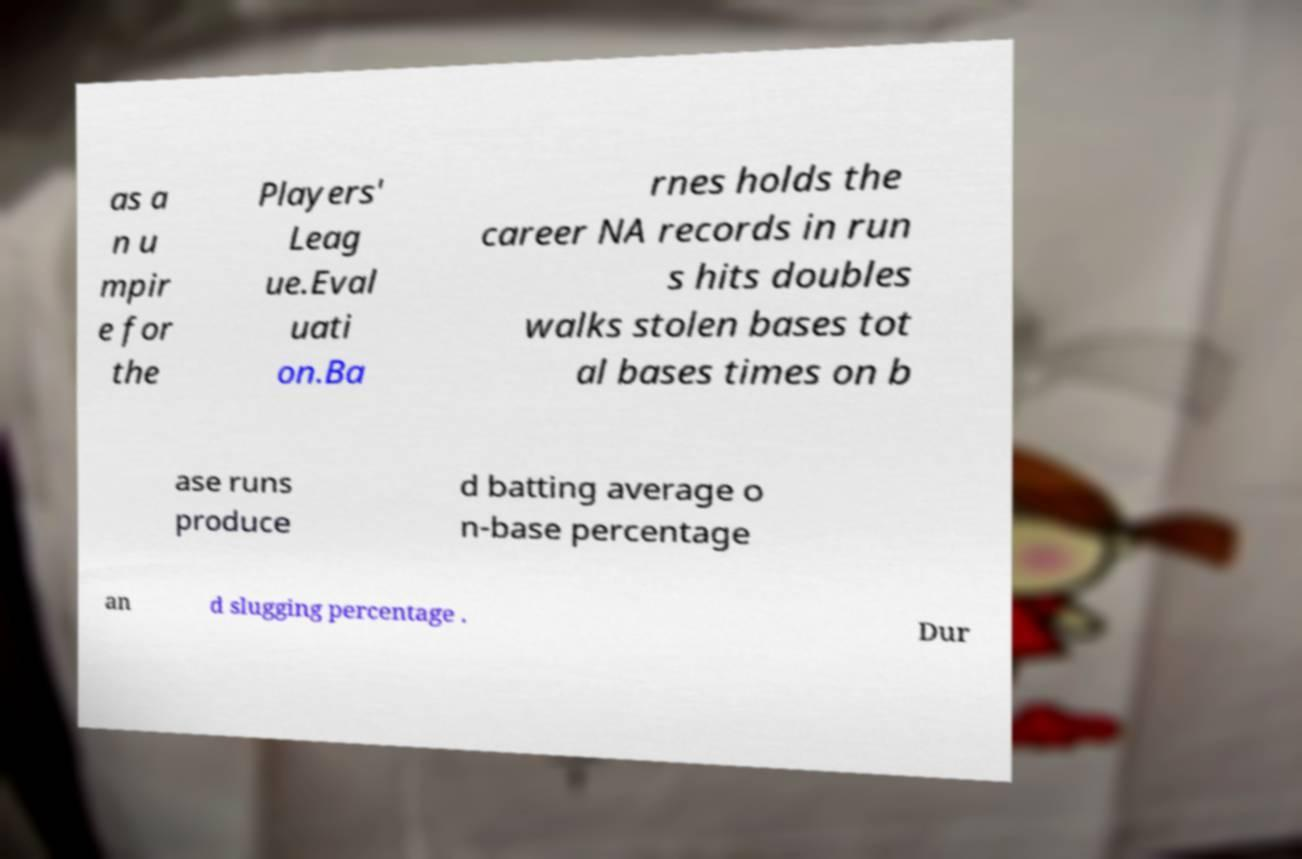Please identify and transcribe the text found in this image. as a n u mpir e for the Players' Leag ue.Eval uati on.Ba rnes holds the career NA records in run s hits doubles walks stolen bases tot al bases times on b ase runs produce d batting average o n-base percentage an d slugging percentage . Dur 